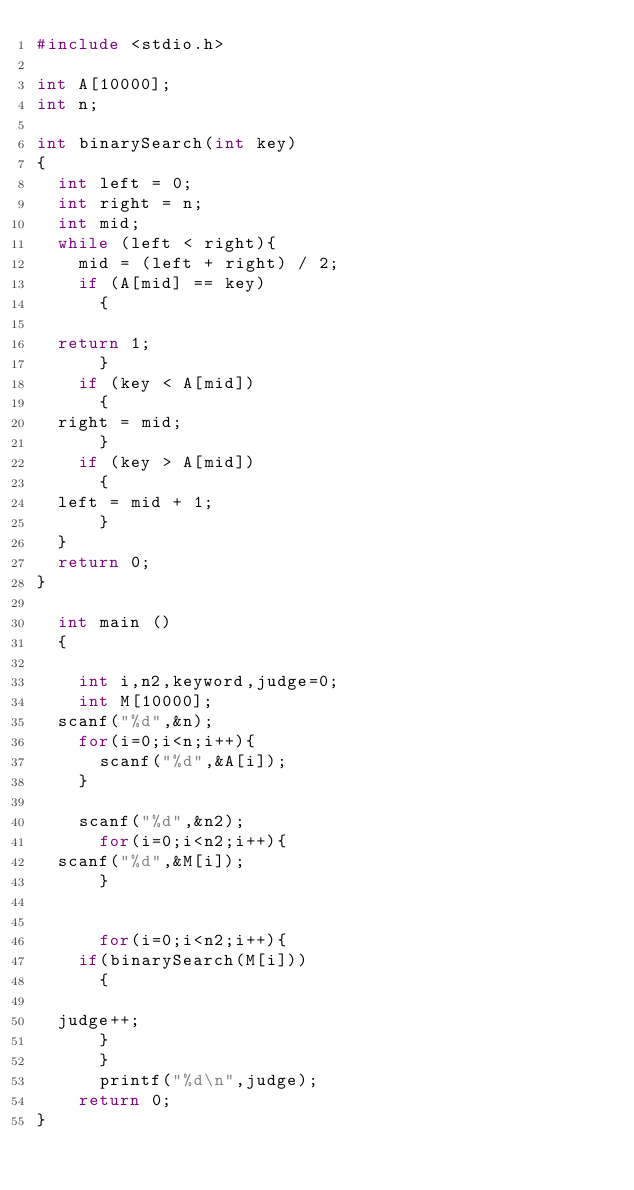<code> <loc_0><loc_0><loc_500><loc_500><_C_>#include <stdio.h>

int A[10000];
int n;

int binarySearch(int key)
{
  int left = 0;
  int right = n;
  int mid;
  while (left < right){
    mid = (left + right) / 2;
    if (A[mid] == key)
      {

	return 1;
      }
    if (key < A[mid])
      {
	right = mid;
      }
    if (key > A[mid])
      {
	left = mid + 1;
      }
  }
  return 0;
}
      
  int main ()
  {

    int i,n2,keyword,judge=0;
    int M[10000];
  scanf("%d",&n);
    for(i=0;i<n;i++){
      scanf("%d",&A[i]);
    }
  
    scanf("%d",&n2);
      for(i=0;i<n2;i++){
	scanf("%d",&M[i]);
      }
      
 
      for(i=0;i<n2;i++){    
    if(binarySearch(M[i]))
      {

	judge++;
      }
      }
      printf("%d\n",judge);
    return 0;
}</code> 